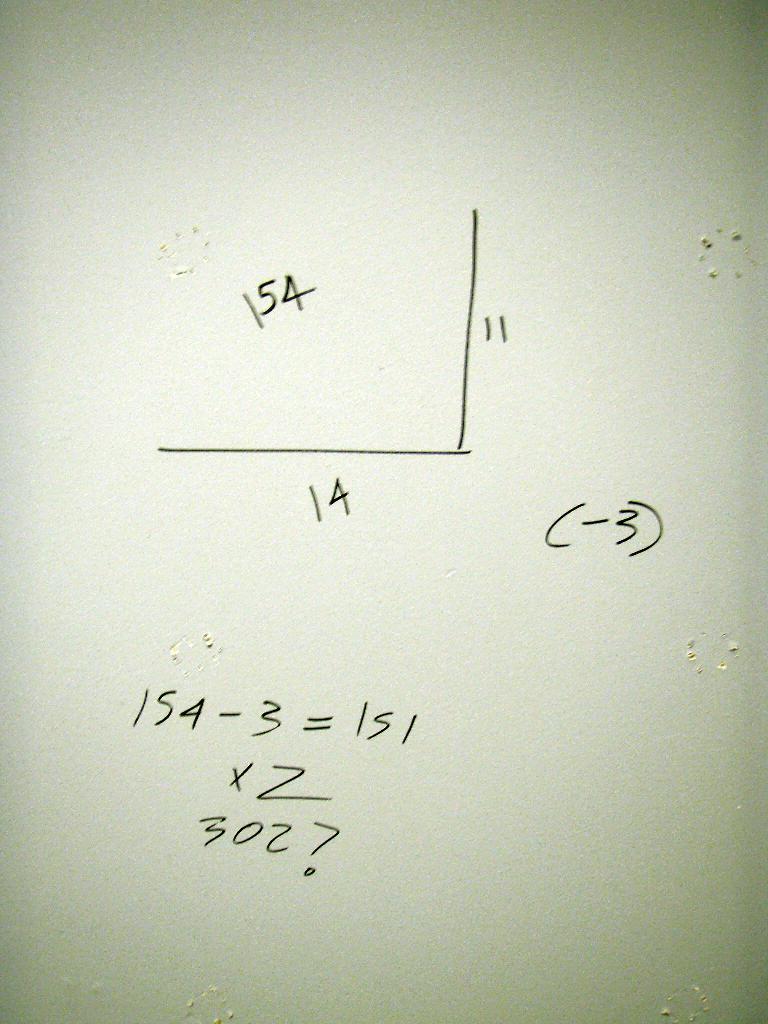What is the height of the shape?
Provide a succinct answer. 11. What is the width of the shape?
Provide a short and direct response. 14. 